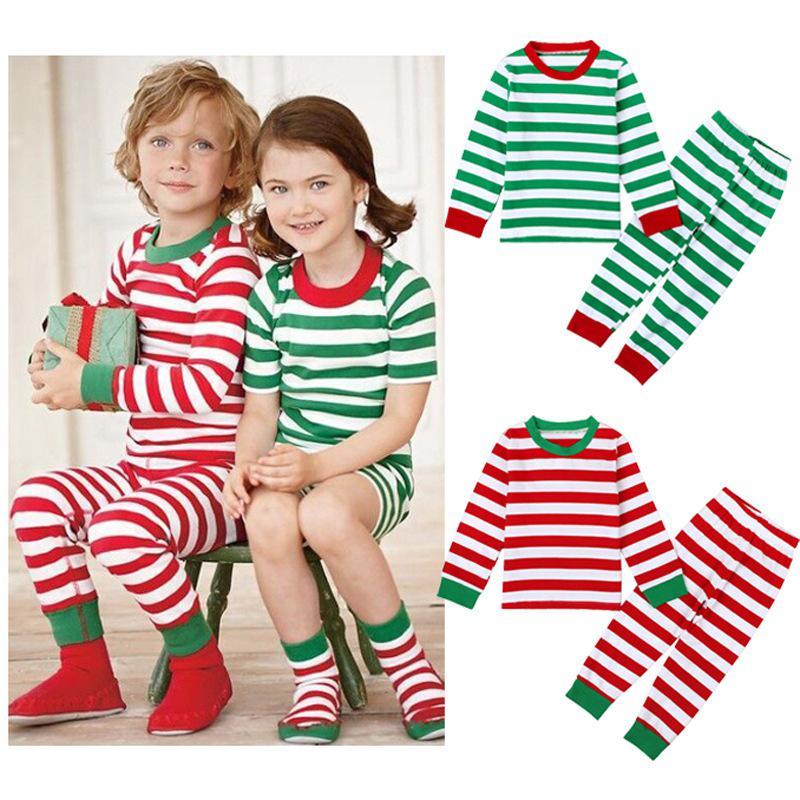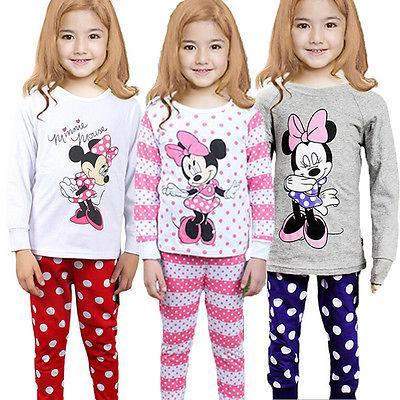The first image is the image on the left, the second image is the image on the right. Assess this claim about the two images: "There are more kids in the image on the right than in the image on the left.". Correct or not? Answer yes or no. Yes. The first image is the image on the left, the second image is the image on the right. Examine the images to the left and right. Is the description "One image shows two sleepwear outfits that feature the face of a Disney princess-type character on the front." accurate? Answer yes or no. No. 